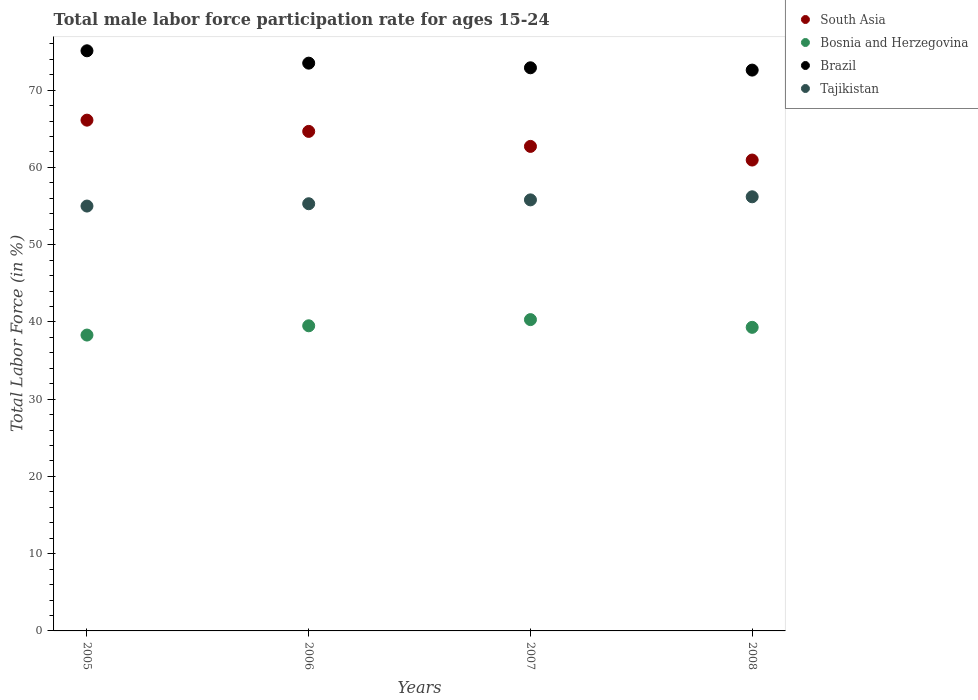How many different coloured dotlines are there?
Provide a short and direct response. 4. Is the number of dotlines equal to the number of legend labels?
Your answer should be very brief. Yes. What is the male labor force participation rate in Brazil in 2006?
Your response must be concise. 73.5. Across all years, what is the maximum male labor force participation rate in Brazil?
Your answer should be compact. 75.1. Across all years, what is the minimum male labor force participation rate in Brazil?
Give a very brief answer. 72.6. In which year was the male labor force participation rate in South Asia maximum?
Your answer should be very brief. 2005. What is the total male labor force participation rate in Bosnia and Herzegovina in the graph?
Make the answer very short. 157.4. What is the difference between the male labor force participation rate in Brazil in 2005 and that in 2008?
Make the answer very short. 2.5. What is the difference between the male labor force participation rate in South Asia in 2006 and the male labor force participation rate in Bosnia and Herzegovina in 2005?
Provide a succinct answer. 26.37. What is the average male labor force participation rate in Bosnia and Herzegovina per year?
Give a very brief answer. 39.35. In the year 2005, what is the difference between the male labor force participation rate in Tajikistan and male labor force participation rate in South Asia?
Ensure brevity in your answer.  -11.12. What is the ratio of the male labor force participation rate in South Asia in 2005 to that in 2008?
Your answer should be very brief. 1.08. Is the male labor force participation rate in Tajikistan in 2005 less than that in 2006?
Your answer should be compact. Yes. Is the difference between the male labor force participation rate in Tajikistan in 2006 and 2007 greater than the difference between the male labor force participation rate in South Asia in 2006 and 2007?
Your answer should be very brief. No. What is the difference between the highest and the second highest male labor force participation rate in South Asia?
Give a very brief answer. 1.46. What is the difference between the highest and the lowest male labor force participation rate in South Asia?
Your response must be concise. 5.16. Is it the case that in every year, the sum of the male labor force participation rate in Tajikistan and male labor force participation rate in South Asia  is greater than the sum of male labor force participation rate in Bosnia and Herzegovina and male labor force participation rate in Brazil?
Offer a very short reply. No. Is it the case that in every year, the sum of the male labor force participation rate in Tajikistan and male labor force participation rate in Brazil  is greater than the male labor force participation rate in Bosnia and Herzegovina?
Offer a very short reply. Yes. Is the male labor force participation rate in Bosnia and Herzegovina strictly greater than the male labor force participation rate in Tajikistan over the years?
Keep it short and to the point. No. Is the male labor force participation rate in Brazil strictly less than the male labor force participation rate in Tajikistan over the years?
Offer a very short reply. No. How many dotlines are there?
Offer a terse response. 4. How many years are there in the graph?
Your answer should be very brief. 4. What is the difference between two consecutive major ticks on the Y-axis?
Keep it short and to the point. 10. Are the values on the major ticks of Y-axis written in scientific E-notation?
Offer a very short reply. No. Does the graph contain any zero values?
Provide a short and direct response. No. Does the graph contain grids?
Offer a very short reply. No. Where does the legend appear in the graph?
Offer a terse response. Top right. How many legend labels are there?
Keep it short and to the point. 4. How are the legend labels stacked?
Make the answer very short. Vertical. What is the title of the graph?
Provide a succinct answer. Total male labor force participation rate for ages 15-24. Does "Bangladesh" appear as one of the legend labels in the graph?
Ensure brevity in your answer.  No. What is the label or title of the Y-axis?
Ensure brevity in your answer.  Total Labor Force (in %). What is the Total Labor Force (in %) in South Asia in 2005?
Provide a short and direct response. 66.12. What is the Total Labor Force (in %) of Bosnia and Herzegovina in 2005?
Your response must be concise. 38.3. What is the Total Labor Force (in %) of Brazil in 2005?
Provide a short and direct response. 75.1. What is the Total Labor Force (in %) in Tajikistan in 2005?
Offer a very short reply. 55. What is the Total Labor Force (in %) in South Asia in 2006?
Keep it short and to the point. 64.67. What is the Total Labor Force (in %) in Bosnia and Herzegovina in 2006?
Your answer should be very brief. 39.5. What is the Total Labor Force (in %) in Brazil in 2006?
Offer a very short reply. 73.5. What is the Total Labor Force (in %) of Tajikistan in 2006?
Give a very brief answer. 55.3. What is the Total Labor Force (in %) of South Asia in 2007?
Make the answer very short. 62.72. What is the Total Labor Force (in %) in Bosnia and Herzegovina in 2007?
Offer a terse response. 40.3. What is the Total Labor Force (in %) of Brazil in 2007?
Provide a short and direct response. 72.9. What is the Total Labor Force (in %) of Tajikistan in 2007?
Offer a very short reply. 55.8. What is the Total Labor Force (in %) of South Asia in 2008?
Your answer should be compact. 60.96. What is the Total Labor Force (in %) of Bosnia and Herzegovina in 2008?
Make the answer very short. 39.3. What is the Total Labor Force (in %) of Brazil in 2008?
Your answer should be very brief. 72.6. What is the Total Labor Force (in %) of Tajikistan in 2008?
Give a very brief answer. 56.2. Across all years, what is the maximum Total Labor Force (in %) in South Asia?
Your answer should be compact. 66.12. Across all years, what is the maximum Total Labor Force (in %) of Bosnia and Herzegovina?
Give a very brief answer. 40.3. Across all years, what is the maximum Total Labor Force (in %) in Brazil?
Make the answer very short. 75.1. Across all years, what is the maximum Total Labor Force (in %) in Tajikistan?
Make the answer very short. 56.2. Across all years, what is the minimum Total Labor Force (in %) of South Asia?
Provide a succinct answer. 60.96. Across all years, what is the minimum Total Labor Force (in %) of Bosnia and Herzegovina?
Give a very brief answer. 38.3. Across all years, what is the minimum Total Labor Force (in %) in Brazil?
Give a very brief answer. 72.6. What is the total Total Labor Force (in %) of South Asia in the graph?
Your answer should be compact. 254.47. What is the total Total Labor Force (in %) of Bosnia and Herzegovina in the graph?
Provide a succinct answer. 157.4. What is the total Total Labor Force (in %) of Brazil in the graph?
Offer a terse response. 294.1. What is the total Total Labor Force (in %) in Tajikistan in the graph?
Your response must be concise. 222.3. What is the difference between the Total Labor Force (in %) of South Asia in 2005 and that in 2006?
Your response must be concise. 1.46. What is the difference between the Total Labor Force (in %) of South Asia in 2005 and that in 2007?
Provide a succinct answer. 3.4. What is the difference between the Total Labor Force (in %) in South Asia in 2005 and that in 2008?
Provide a short and direct response. 5.16. What is the difference between the Total Labor Force (in %) in Bosnia and Herzegovina in 2005 and that in 2008?
Provide a short and direct response. -1. What is the difference between the Total Labor Force (in %) in Brazil in 2005 and that in 2008?
Ensure brevity in your answer.  2.5. What is the difference between the Total Labor Force (in %) in South Asia in 2006 and that in 2007?
Offer a very short reply. 1.94. What is the difference between the Total Labor Force (in %) of Bosnia and Herzegovina in 2006 and that in 2007?
Your response must be concise. -0.8. What is the difference between the Total Labor Force (in %) of Brazil in 2006 and that in 2007?
Offer a terse response. 0.6. What is the difference between the Total Labor Force (in %) in Tajikistan in 2006 and that in 2007?
Offer a terse response. -0.5. What is the difference between the Total Labor Force (in %) of South Asia in 2006 and that in 2008?
Your answer should be very brief. 3.71. What is the difference between the Total Labor Force (in %) of Brazil in 2006 and that in 2008?
Make the answer very short. 0.9. What is the difference between the Total Labor Force (in %) in Tajikistan in 2006 and that in 2008?
Offer a terse response. -0.9. What is the difference between the Total Labor Force (in %) in South Asia in 2007 and that in 2008?
Offer a very short reply. 1.77. What is the difference between the Total Labor Force (in %) of Brazil in 2007 and that in 2008?
Give a very brief answer. 0.3. What is the difference between the Total Labor Force (in %) in South Asia in 2005 and the Total Labor Force (in %) in Bosnia and Herzegovina in 2006?
Give a very brief answer. 26.62. What is the difference between the Total Labor Force (in %) of South Asia in 2005 and the Total Labor Force (in %) of Brazil in 2006?
Provide a short and direct response. -7.38. What is the difference between the Total Labor Force (in %) of South Asia in 2005 and the Total Labor Force (in %) of Tajikistan in 2006?
Ensure brevity in your answer.  10.82. What is the difference between the Total Labor Force (in %) of Bosnia and Herzegovina in 2005 and the Total Labor Force (in %) of Brazil in 2006?
Your answer should be compact. -35.2. What is the difference between the Total Labor Force (in %) in Bosnia and Herzegovina in 2005 and the Total Labor Force (in %) in Tajikistan in 2006?
Your answer should be very brief. -17. What is the difference between the Total Labor Force (in %) of Brazil in 2005 and the Total Labor Force (in %) of Tajikistan in 2006?
Keep it short and to the point. 19.8. What is the difference between the Total Labor Force (in %) in South Asia in 2005 and the Total Labor Force (in %) in Bosnia and Herzegovina in 2007?
Ensure brevity in your answer.  25.82. What is the difference between the Total Labor Force (in %) in South Asia in 2005 and the Total Labor Force (in %) in Brazil in 2007?
Your answer should be very brief. -6.78. What is the difference between the Total Labor Force (in %) in South Asia in 2005 and the Total Labor Force (in %) in Tajikistan in 2007?
Provide a short and direct response. 10.32. What is the difference between the Total Labor Force (in %) in Bosnia and Herzegovina in 2005 and the Total Labor Force (in %) in Brazil in 2007?
Offer a very short reply. -34.6. What is the difference between the Total Labor Force (in %) of Bosnia and Herzegovina in 2005 and the Total Labor Force (in %) of Tajikistan in 2007?
Your response must be concise. -17.5. What is the difference between the Total Labor Force (in %) of Brazil in 2005 and the Total Labor Force (in %) of Tajikistan in 2007?
Your answer should be very brief. 19.3. What is the difference between the Total Labor Force (in %) of South Asia in 2005 and the Total Labor Force (in %) of Bosnia and Herzegovina in 2008?
Offer a terse response. 26.82. What is the difference between the Total Labor Force (in %) in South Asia in 2005 and the Total Labor Force (in %) in Brazil in 2008?
Provide a succinct answer. -6.48. What is the difference between the Total Labor Force (in %) of South Asia in 2005 and the Total Labor Force (in %) of Tajikistan in 2008?
Your answer should be compact. 9.92. What is the difference between the Total Labor Force (in %) of Bosnia and Herzegovina in 2005 and the Total Labor Force (in %) of Brazil in 2008?
Offer a very short reply. -34.3. What is the difference between the Total Labor Force (in %) of Bosnia and Herzegovina in 2005 and the Total Labor Force (in %) of Tajikistan in 2008?
Make the answer very short. -17.9. What is the difference between the Total Labor Force (in %) in Brazil in 2005 and the Total Labor Force (in %) in Tajikistan in 2008?
Offer a terse response. 18.9. What is the difference between the Total Labor Force (in %) of South Asia in 2006 and the Total Labor Force (in %) of Bosnia and Herzegovina in 2007?
Provide a short and direct response. 24.37. What is the difference between the Total Labor Force (in %) in South Asia in 2006 and the Total Labor Force (in %) in Brazil in 2007?
Make the answer very short. -8.23. What is the difference between the Total Labor Force (in %) of South Asia in 2006 and the Total Labor Force (in %) of Tajikistan in 2007?
Your answer should be compact. 8.87. What is the difference between the Total Labor Force (in %) of Bosnia and Herzegovina in 2006 and the Total Labor Force (in %) of Brazil in 2007?
Offer a very short reply. -33.4. What is the difference between the Total Labor Force (in %) of Bosnia and Herzegovina in 2006 and the Total Labor Force (in %) of Tajikistan in 2007?
Offer a terse response. -16.3. What is the difference between the Total Labor Force (in %) of South Asia in 2006 and the Total Labor Force (in %) of Bosnia and Herzegovina in 2008?
Your answer should be compact. 25.37. What is the difference between the Total Labor Force (in %) in South Asia in 2006 and the Total Labor Force (in %) in Brazil in 2008?
Your answer should be compact. -7.93. What is the difference between the Total Labor Force (in %) in South Asia in 2006 and the Total Labor Force (in %) in Tajikistan in 2008?
Your response must be concise. 8.47. What is the difference between the Total Labor Force (in %) of Bosnia and Herzegovina in 2006 and the Total Labor Force (in %) of Brazil in 2008?
Ensure brevity in your answer.  -33.1. What is the difference between the Total Labor Force (in %) in Bosnia and Herzegovina in 2006 and the Total Labor Force (in %) in Tajikistan in 2008?
Offer a terse response. -16.7. What is the difference between the Total Labor Force (in %) of South Asia in 2007 and the Total Labor Force (in %) of Bosnia and Herzegovina in 2008?
Provide a succinct answer. 23.42. What is the difference between the Total Labor Force (in %) in South Asia in 2007 and the Total Labor Force (in %) in Brazil in 2008?
Offer a terse response. -9.88. What is the difference between the Total Labor Force (in %) of South Asia in 2007 and the Total Labor Force (in %) of Tajikistan in 2008?
Ensure brevity in your answer.  6.52. What is the difference between the Total Labor Force (in %) in Bosnia and Herzegovina in 2007 and the Total Labor Force (in %) in Brazil in 2008?
Give a very brief answer. -32.3. What is the difference between the Total Labor Force (in %) of Bosnia and Herzegovina in 2007 and the Total Labor Force (in %) of Tajikistan in 2008?
Keep it short and to the point. -15.9. What is the average Total Labor Force (in %) of South Asia per year?
Keep it short and to the point. 63.62. What is the average Total Labor Force (in %) of Bosnia and Herzegovina per year?
Keep it short and to the point. 39.35. What is the average Total Labor Force (in %) in Brazil per year?
Make the answer very short. 73.53. What is the average Total Labor Force (in %) in Tajikistan per year?
Ensure brevity in your answer.  55.58. In the year 2005, what is the difference between the Total Labor Force (in %) of South Asia and Total Labor Force (in %) of Bosnia and Herzegovina?
Keep it short and to the point. 27.82. In the year 2005, what is the difference between the Total Labor Force (in %) in South Asia and Total Labor Force (in %) in Brazil?
Your response must be concise. -8.98. In the year 2005, what is the difference between the Total Labor Force (in %) in South Asia and Total Labor Force (in %) in Tajikistan?
Offer a terse response. 11.12. In the year 2005, what is the difference between the Total Labor Force (in %) in Bosnia and Herzegovina and Total Labor Force (in %) in Brazil?
Your answer should be compact. -36.8. In the year 2005, what is the difference between the Total Labor Force (in %) of Bosnia and Herzegovina and Total Labor Force (in %) of Tajikistan?
Give a very brief answer. -16.7. In the year 2005, what is the difference between the Total Labor Force (in %) of Brazil and Total Labor Force (in %) of Tajikistan?
Your response must be concise. 20.1. In the year 2006, what is the difference between the Total Labor Force (in %) of South Asia and Total Labor Force (in %) of Bosnia and Herzegovina?
Offer a terse response. 25.17. In the year 2006, what is the difference between the Total Labor Force (in %) of South Asia and Total Labor Force (in %) of Brazil?
Ensure brevity in your answer.  -8.83. In the year 2006, what is the difference between the Total Labor Force (in %) in South Asia and Total Labor Force (in %) in Tajikistan?
Give a very brief answer. 9.37. In the year 2006, what is the difference between the Total Labor Force (in %) in Bosnia and Herzegovina and Total Labor Force (in %) in Brazil?
Offer a terse response. -34. In the year 2006, what is the difference between the Total Labor Force (in %) of Bosnia and Herzegovina and Total Labor Force (in %) of Tajikistan?
Give a very brief answer. -15.8. In the year 2006, what is the difference between the Total Labor Force (in %) in Brazil and Total Labor Force (in %) in Tajikistan?
Your answer should be very brief. 18.2. In the year 2007, what is the difference between the Total Labor Force (in %) of South Asia and Total Labor Force (in %) of Bosnia and Herzegovina?
Make the answer very short. 22.42. In the year 2007, what is the difference between the Total Labor Force (in %) in South Asia and Total Labor Force (in %) in Brazil?
Keep it short and to the point. -10.18. In the year 2007, what is the difference between the Total Labor Force (in %) of South Asia and Total Labor Force (in %) of Tajikistan?
Offer a terse response. 6.92. In the year 2007, what is the difference between the Total Labor Force (in %) of Bosnia and Herzegovina and Total Labor Force (in %) of Brazil?
Your answer should be compact. -32.6. In the year 2007, what is the difference between the Total Labor Force (in %) in Bosnia and Herzegovina and Total Labor Force (in %) in Tajikistan?
Provide a short and direct response. -15.5. In the year 2008, what is the difference between the Total Labor Force (in %) of South Asia and Total Labor Force (in %) of Bosnia and Herzegovina?
Give a very brief answer. 21.66. In the year 2008, what is the difference between the Total Labor Force (in %) in South Asia and Total Labor Force (in %) in Brazil?
Your answer should be compact. -11.64. In the year 2008, what is the difference between the Total Labor Force (in %) of South Asia and Total Labor Force (in %) of Tajikistan?
Your answer should be compact. 4.76. In the year 2008, what is the difference between the Total Labor Force (in %) in Bosnia and Herzegovina and Total Labor Force (in %) in Brazil?
Your response must be concise. -33.3. In the year 2008, what is the difference between the Total Labor Force (in %) of Bosnia and Herzegovina and Total Labor Force (in %) of Tajikistan?
Ensure brevity in your answer.  -16.9. What is the ratio of the Total Labor Force (in %) in South Asia in 2005 to that in 2006?
Offer a very short reply. 1.02. What is the ratio of the Total Labor Force (in %) in Bosnia and Herzegovina in 2005 to that in 2006?
Your response must be concise. 0.97. What is the ratio of the Total Labor Force (in %) of Brazil in 2005 to that in 2006?
Keep it short and to the point. 1.02. What is the ratio of the Total Labor Force (in %) of South Asia in 2005 to that in 2007?
Make the answer very short. 1.05. What is the ratio of the Total Labor Force (in %) in Bosnia and Herzegovina in 2005 to that in 2007?
Your answer should be compact. 0.95. What is the ratio of the Total Labor Force (in %) in Brazil in 2005 to that in 2007?
Your response must be concise. 1.03. What is the ratio of the Total Labor Force (in %) in Tajikistan in 2005 to that in 2007?
Your response must be concise. 0.99. What is the ratio of the Total Labor Force (in %) of South Asia in 2005 to that in 2008?
Your answer should be compact. 1.08. What is the ratio of the Total Labor Force (in %) of Bosnia and Herzegovina in 2005 to that in 2008?
Give a very brief answer. 0.97. What is the ratio of the Total Labor Force (in %) of Brazil in 2005 to that in 2008?
Keep it short and to the point. 1.03. What is the ratio of the Total Labor Force (in %) of Tajikistan in 2005 to that in 2008?
Keep it short and to the point. 0.98. What is the ratio of the Total Labor Force (in %) of South Asia in 2006 to that in 2007?
Provide a succinct answer. 1.03. What is the ratio of the Total Labor Force (in %) in Bosnia and Herzegovina in 2006 to that in 2007?
Ensure brevity in your answer.  0.98. What is the ratio of the Total Labor Force (in %) of Brazil in 2006 to that in 2007?
Provide a succinct answer. 1.01. What is the ratio of the Total Labor Force (in %) of South Asia in 2006 to that in 2008?
Provide a short and direct response. 1.06. What is the ratio of the Total Labor Force (in %) of Bosnia and Herzegovina in 2006 to that in 2008?
Provide a short and direct response. 1.01. What is the ratio of the Total Labor Force (in %) of Brazil in 2006 to that in 2008?
Your answer should be compact. 1.01. What is the ratio of the Total Labor Force (in %) in Tajikistan in 2006 to that in 2008?
Offer a very short reply. 0.98. What is the ratio of the Total Labor Force (in %) of South Asia in 2007 to that in 2008?
Ensure brevity in your answer.  1.03. What is the ratio of the Total Labor Force (in %) of Bosnia and Herzegovina in 2007 to that in 2008?
Keep it short and to the point. 1.03. What is the ratio of the Total Labor Force (in %) in Tajikistan in 2007 to that in 2008?
Keep it short and to the point. 0.99. What is the difference between the highest and the second highest Total Labor Force (in %) of South Asia?
Ensure brevity in your answer.  1.46. What is the difference between the highest and the second highest Total Labor Force (in %) in Bosnia and Herzegovina?
Make the answer very short. 0.8. What is the difference between the highest and the second highest Total Labor Force (in %) of Tajikistan?
Your answer should be very brief. 0.4. What is the difference between the highest and the lowest Total Labor Force (in %) of South Asia?
Ensure brevity in your answer.  5.16. What is the difference between the highest and the lowest Total Labor Force (in %) of Brazil?
Provide a succinct answer. 2.5. What is the difference between the highest and the lowest Total Labor Force (in %) in Tajikistan?
Offer a very short reply. 1.2. 